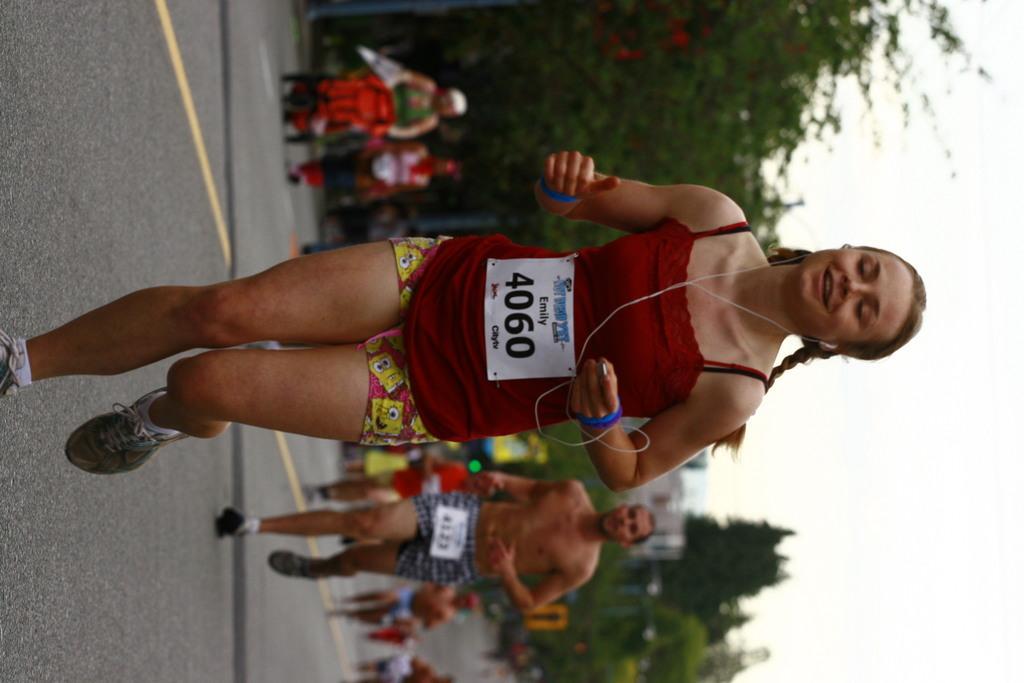Describe this image in one or two sentences. These people are running on the road. Background we can see trees and sky. 